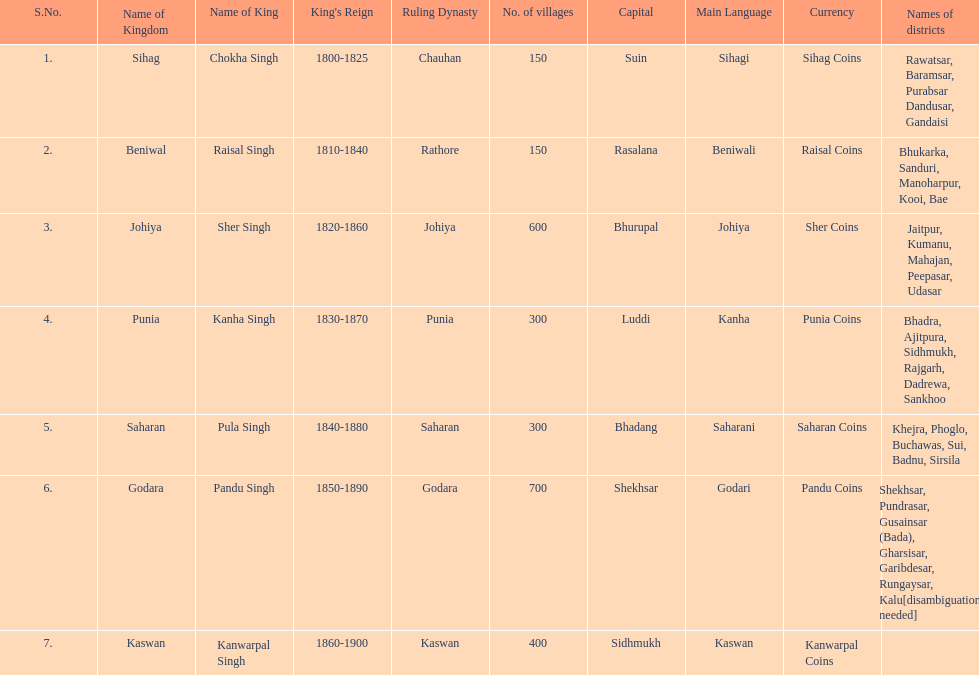How many districts does punia have? 6. 